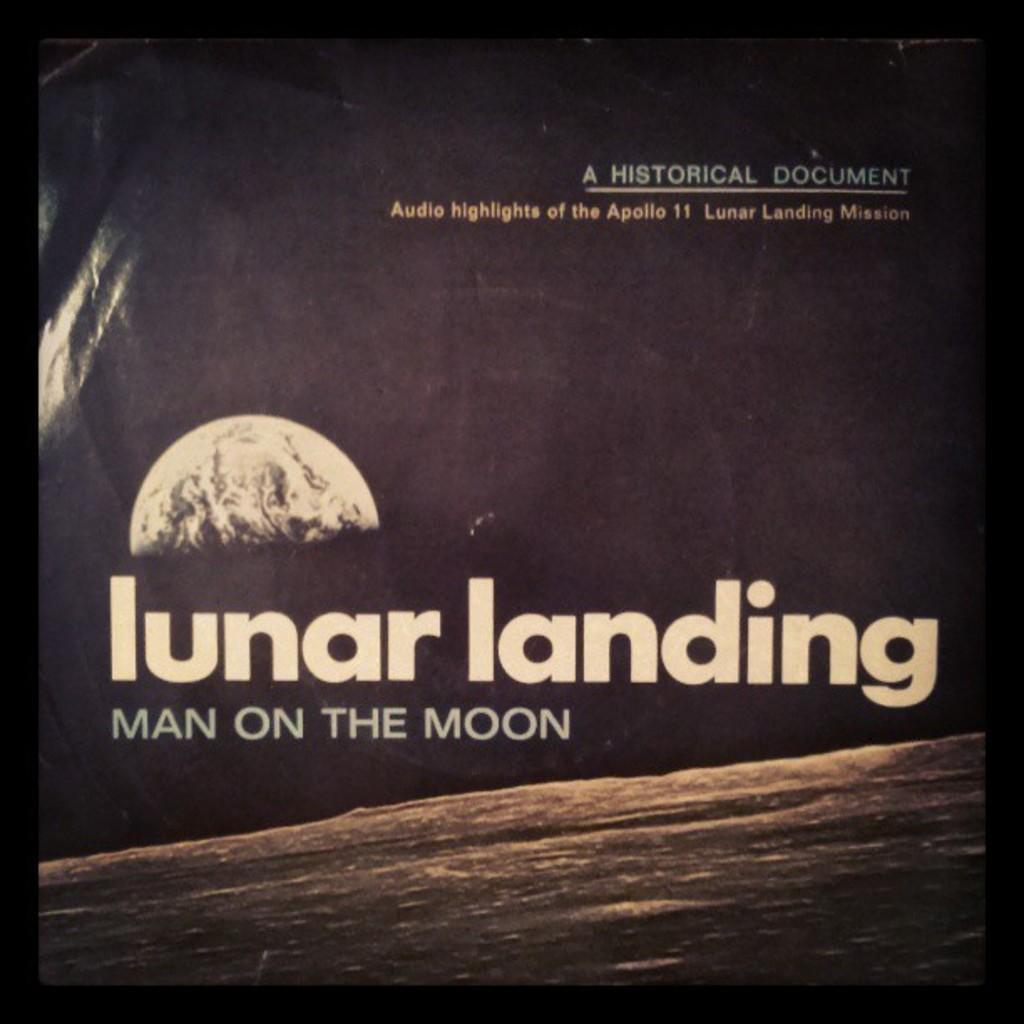What is the main subject of the image? The main subject of the image is a picture of a moon. What else can be seen in the image besides the moon? There is a text written on a paper in the image. How would you describe the overall appearance of the image? The background of the image is dark. Can you tell me how many islands are visible in the image? There are no islands present in the image; it features a picture of a moon and text on a paper. What type of peace symbol can be seen in the image? There is no peace symbol present in the image; it only contains a picture of a moon and text on a paper. 